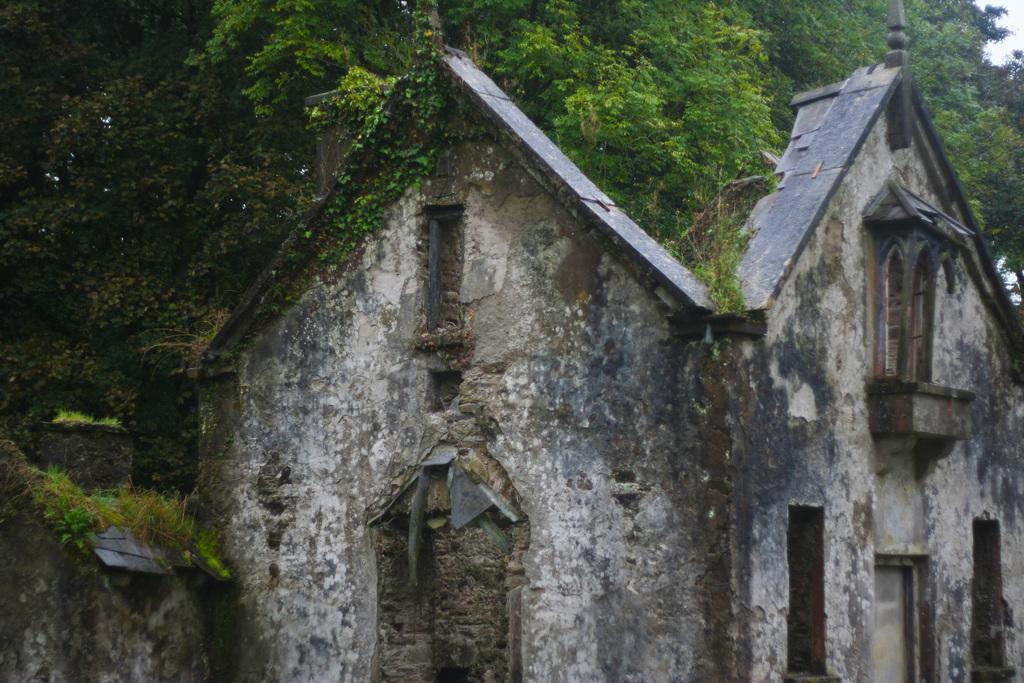What type of houses are depicted in the image? There are mud houses in the image. What features do the mud houses have? The mud houses have doors and windows. What can be seen in the background of the image? There are trees in the background of the image. What type of cloud is covering the mud houses in the image? There is no cloud present in the image; the sky is not visible. What color is the sweater worn by the person standing in front of the mud houses? There is no person or sweater present in the image. 